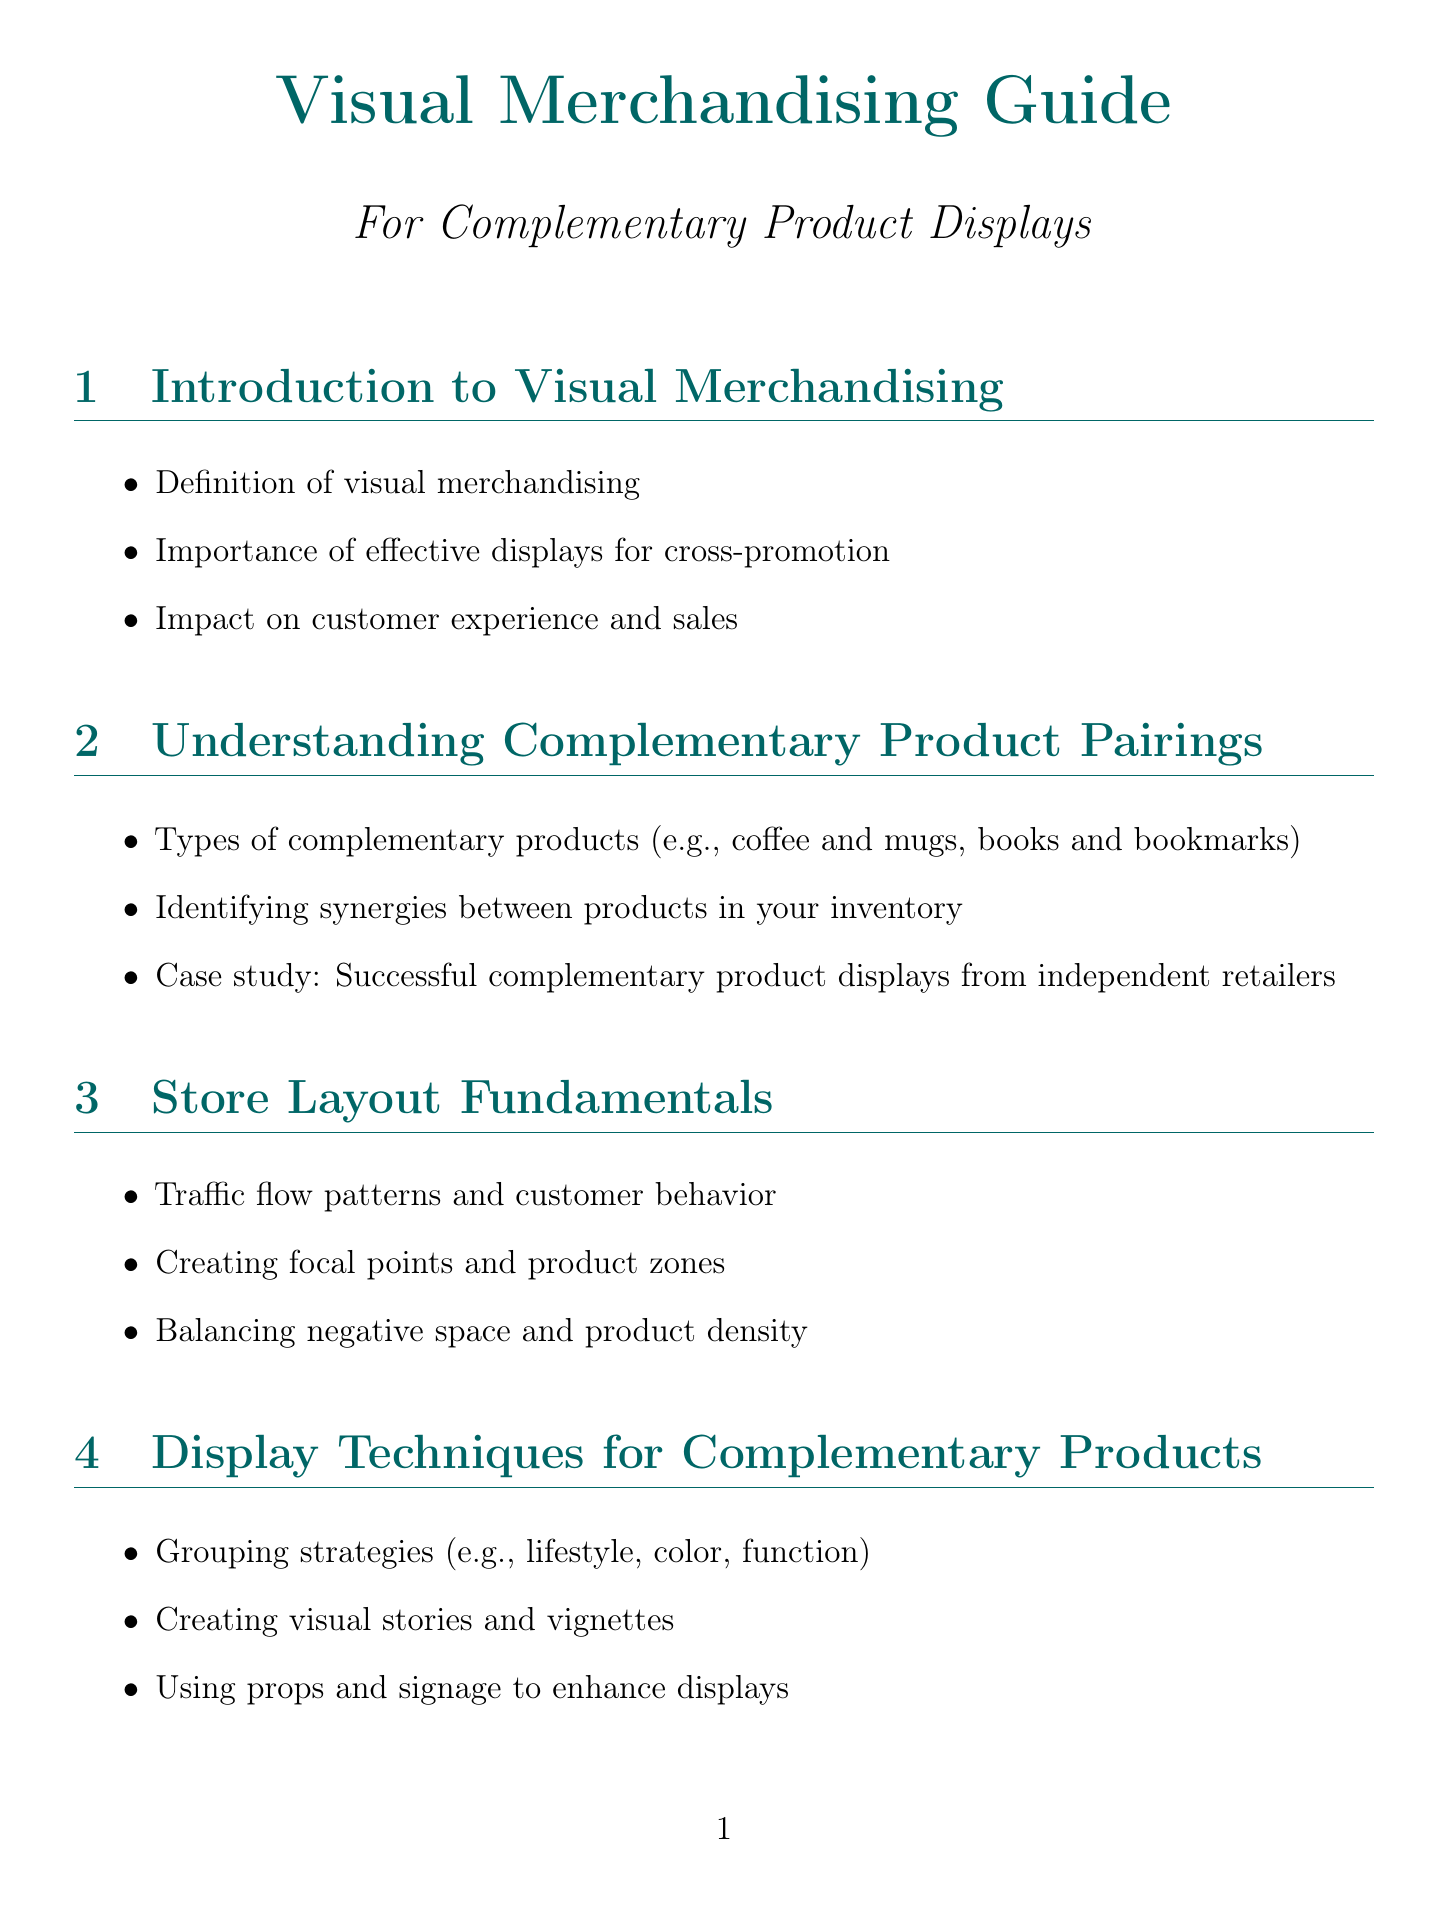What is the title of the manual? The title of the manual is indicated prominently at the beginning, which is "Visual Merchandising Guide."
Answer: Visual Merchandising Guide What are two types of complementary products mentioned? Examples of complementary products are listed in the document, specifically coffee and mugs, books and bookmarks.
Answer: coffee and mugs, books and bookmarks What is one display technique for complementary products? The document lists several techniques, one being "Creating visual stories and vignettes."
Answer: Creating visual stories and vignettes What color is associated with trust and calm? The document states that blue is the color connected with trust and calmness.
Answer: blue How many layout diagrams are presented in the manual? The manual mentions three specific layout diagrams that help illustrate different store layouts.
Answer: 3 What does the red color represent in color psychology? The psychological effect of red as given in the document is excitement, urgency, or passion.
Answer: excitement, urgency, passion What is the name of the layout that encourages exploration? Among the layouts described, the one that promotes exploration is referred to as the "Free-Flow Boutique Layout."
Answer: Free-Flow Boutique Layout What is the concluding section of the manual titled? The last part of the manual provides a summary of strategies titled "Conclusion: Implementing Your Visual Merchandising Strategy."
Answer: Conclusion: Implementing Your Visual Merchandising Strategy 